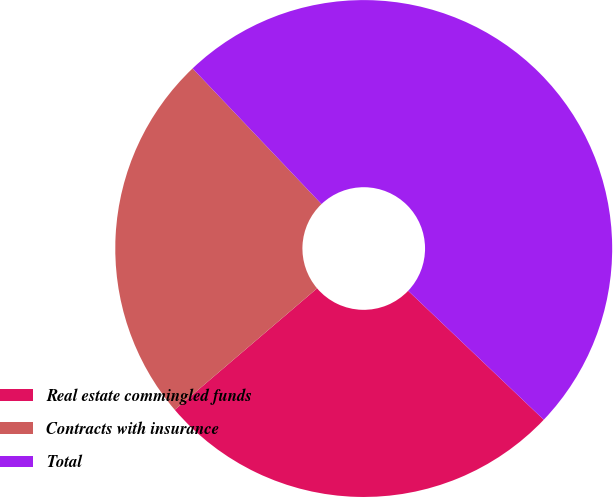<chart> <loc_0><loc_0><loc_500><loc_500><pie_chart><fcel>Real estate commingled funds<fcel>Contracts with insurance<fcel>Total<nl><fcel>26.65%<fcel>24.15%<fcel>49.19%<nl></chart> 